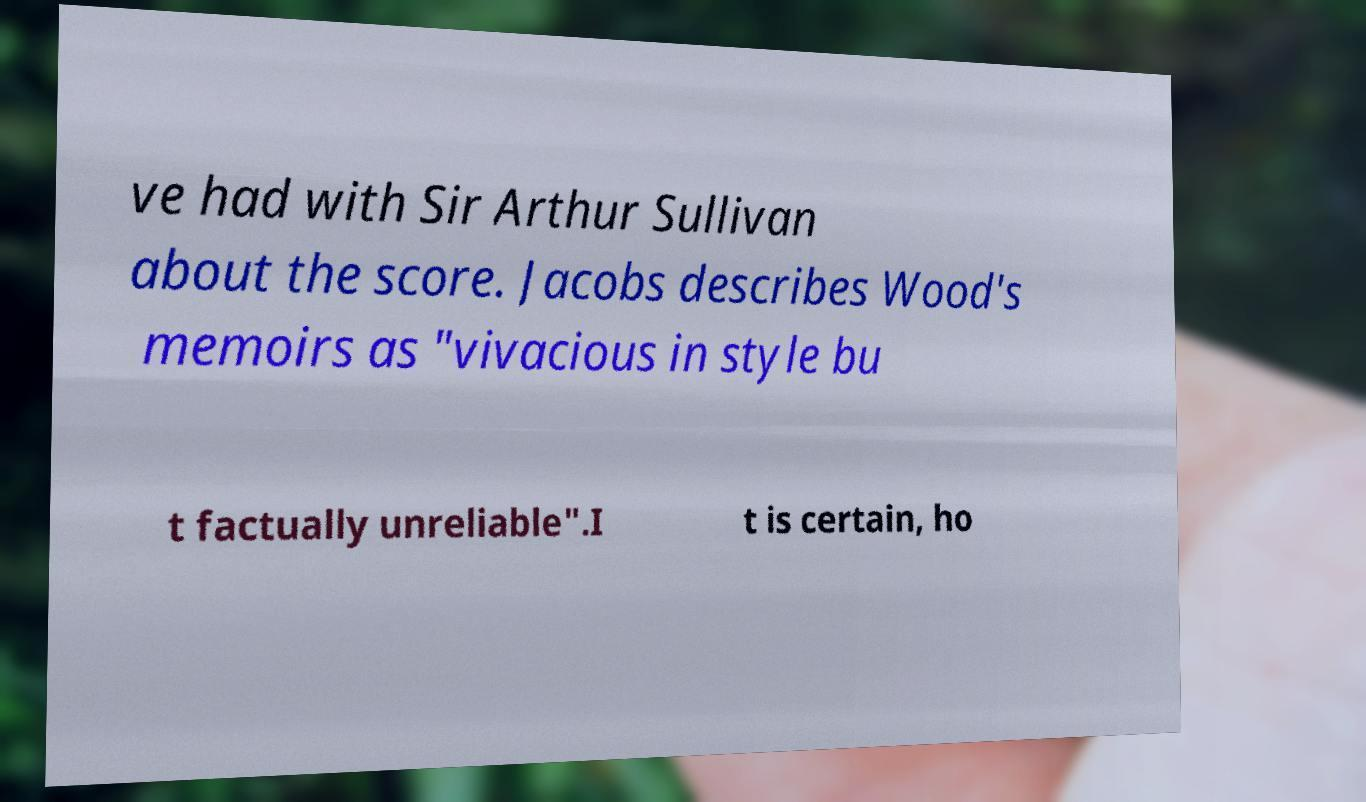For documentation purposes, I need the text within this image transcribed. Could you provide that? ve had with Sir Arthur Sullivan about the score. Jacobs describes Wood's memoirs as "vivacious in style bu t factually unreliable".I t is certain, ho 